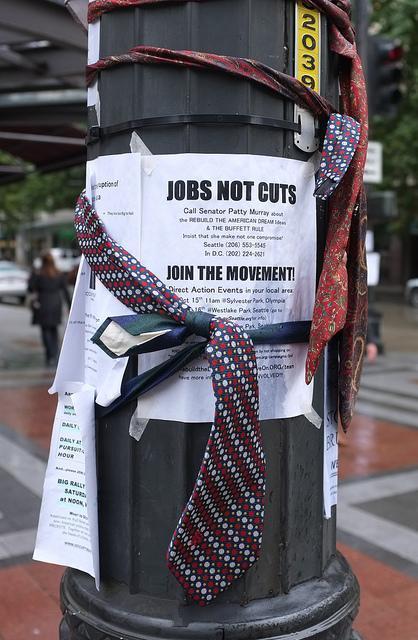How many ties are visible?
Give a very brief answer. 5. 